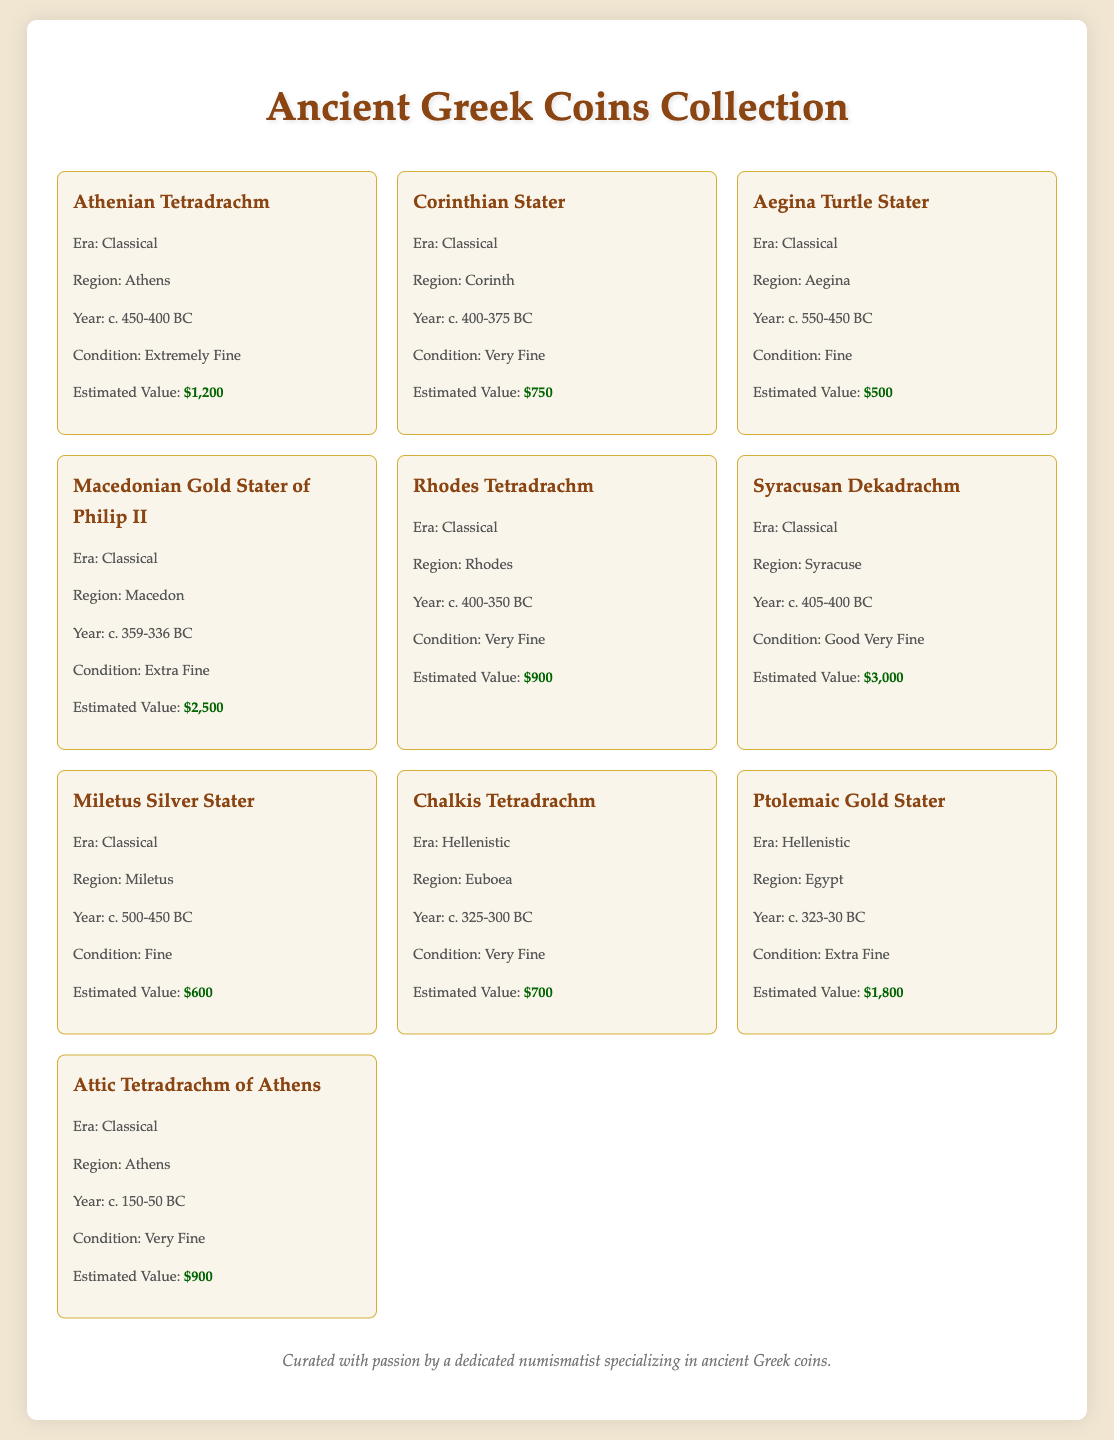What is the earliest year of a coin in the collection? The earliest coin in the collection is the Aegina Turtle Stater, which is from c. 550-450 BC.
Answer: c. 550-450 BC What is the condition of the Macedonian Gold Stater of Philip II? The condition of the Macedonian Gold Stater of Philip II is Extra Fine.
Answer: Extra Fine How many coins are listed in the collection? There are ten coins listed in the collection according to the document.
Answer: 10 What is the estimated value of the Syracusan Dekadrachm? The estimated value of the Syracusan Dekadrachm is $3,000.
Answer: $3,000 Which region is the Ptolemaic Gold Stater from? The Ptolemaic Gold Stater is from the region of Egypt.
Answer: Egypt What is the highest estimated value among the coins? The highest estimated value in the collection is found with the Macedonian Gold Stater of Philip II at $2,500.
Answer: $2,500 Which era does the Chalkis Tetradrachm belong to? The Chalkis Tetradrachm belongs to the Hellenistic era.
Answer: Hellenistic What is the condition of the Athenian Tetradrachm? The condition of the Athenian Tetradrachm is Extremely Fine.
Answer: Extremely Fine How many coins are listed from the Classical era? There are seven coins listed from the Classical era in the collection.
Answer: 7 